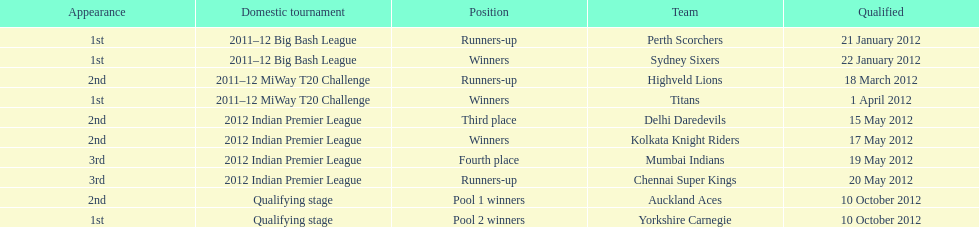Which game came in first in the 2012 indian premier league? Kolkata Knight Riders. 